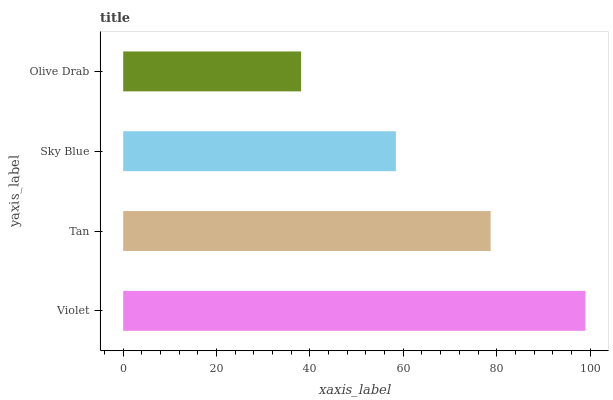Is Olive Drab the minimum?
Answer yes or no. Yes. Is Violet the maximum?
Answer yes or no. Yes. Is Tan the minimum?
Answer yes or no. No. Is Tan the maximum?
Answer yes or no. No. Is Violet greater than Tan?
Answer yes or no. Yes. Is Tan less than Violet?
Answer yes or no. Yes. Is Tan greater than Violet?
Answer yes or no. No. Is Violet less than Tan?
Answer yes or no. No. Is Tan the high median?
Answer yes or no. Yes. Is Sky Blue the low median?
Answer yes or no. Yes. Is Violet the high median?
Answer yes or no. No. Is Violet the low median?
Answer yes or no. No. 